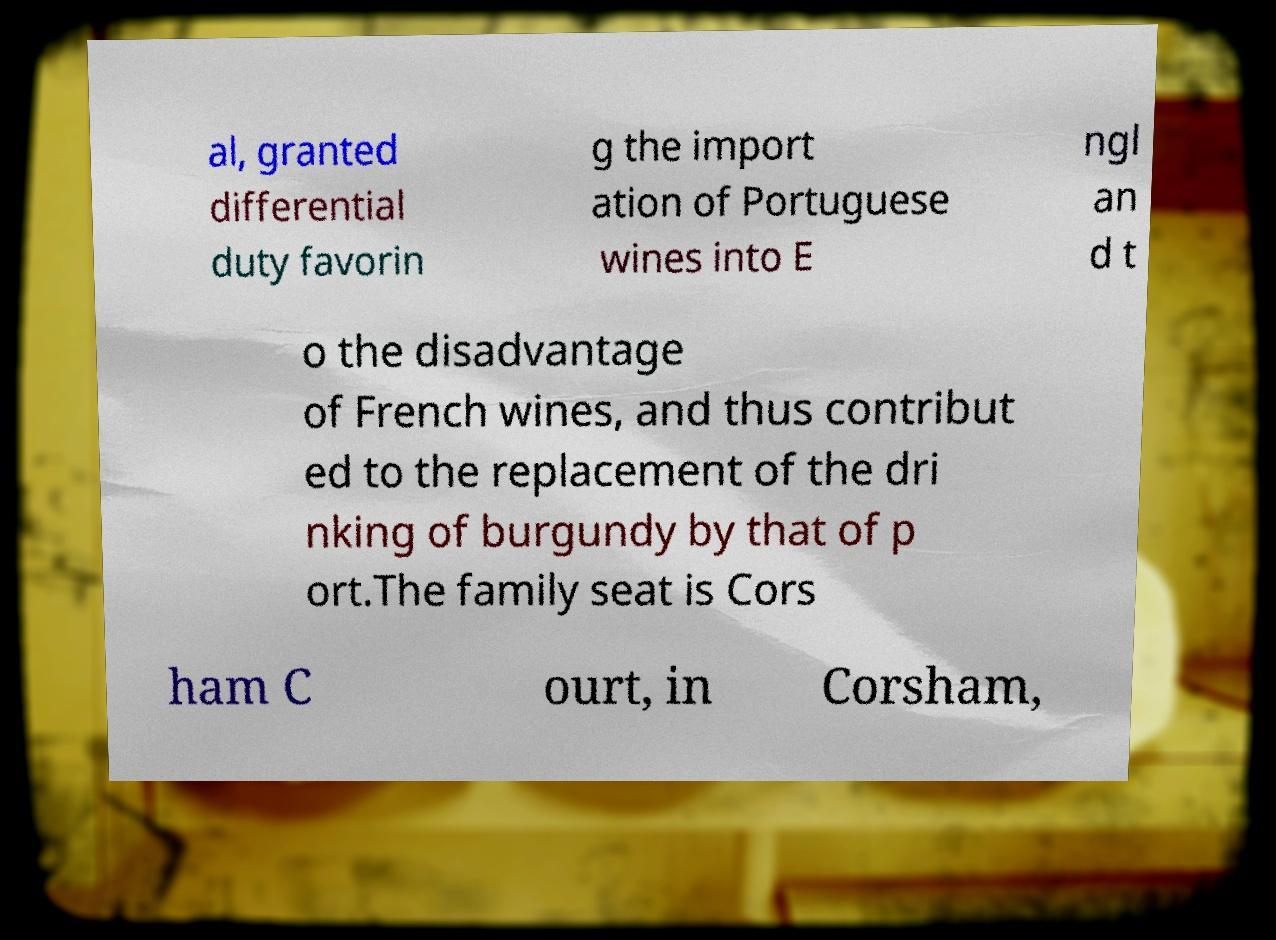What messages or text are displayed in this image? I need them in a readable, typed format. al, granted differential duty favorin g the import ation of Portuguese wines into E ngl an d t o the disadvantage of French wines, and thus contribut ed to the replacement of the dri nking of burgundy by that of p ort.The family seat is Cors ham C ourt, in Corsham, 